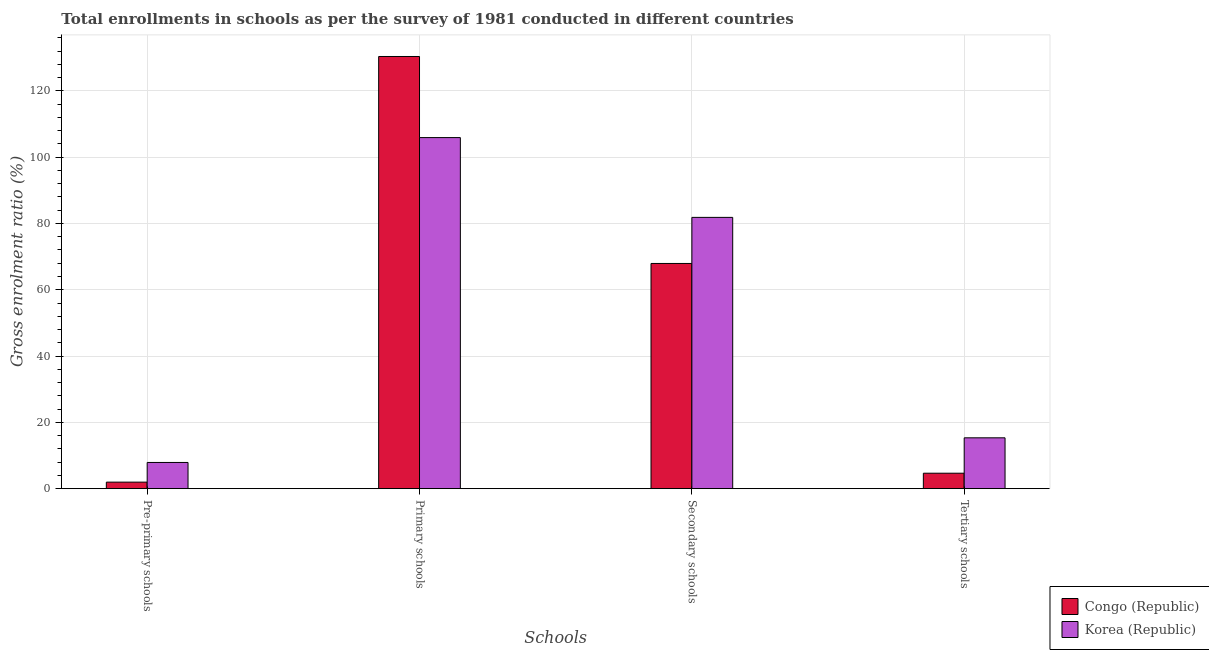Are the number of bars per tick equal to the number of legend labels?
Ensure brevity in your answer.  Yes. Are the number of bars on each tick of the X-axis equal?
Your response must be concise. Yes. How many bars are there on the 1st tick from the left?
Provide a short and direct response. 2. What is the label of the 2nd group of bars from the left?
Ensure brevity in your answer.  Primary schools. What is the gross enrolment ratio in primary schools in Korea (Republic)?
Provide a short and direct response. 105.91. Across all countries, what is the maximum gross enrolment ratio in pre-primary schools?
Give a very brief answer. 7.91. Across all countries, what is the minimum gross enrolment ratio in pre-primary schools?
Provide a succinct answer. 1.98. In which country was the gross enrolment ratio in tertiary schools maximum?
Your answer should be very brief. Korea (Republic). In which country was the gross enrolment ratio in primary schools minimum?
Offer a very short reply. Korea (Republic). What is the total gross enrolment ratio in secondary schools in the graph?
Make the answer very short. 149.78. What is the difference between the gross enrolment ratio in pre-primary schools in Korea (Republic) and that in Congo (Republic)?
Make the answer very short. 5.93. What is the difference between the gross enrolment ratio in secondary schools in Congo (Republic) and the gross enrolment ratio in primary schools in Korea (Republic)?
Ensure brevity in your answer.  -37.97. What is the average gross enrolment ratio in tertiary schools per country?
Your answer should be very brief. 10.01. What is the difference between the gross enrolment ratio in primary schools and gross enrolment ratio in pre-primary schools in Korea (Republic)?
Provide a short and direct response. 98. What is the ratio of the gross enrolment ratio in secondary schools in Korea (Republic) to that in Congo (Republic)?
Your answer should be very brief. 1.2. What is the difference between the highest and the second highest gross enrolment ratio in primary schools?
Keep it short and to the point. 24.47. What is the difference between the highest and the lowest gross enrolment ratio in pre-primary schools?
Your answer should be very brief. 5.93. What does the 1st bar from the left in Pre-primary schools represents?
Your answer should be very brief. Congo (Republic). What does the 2nd bar from the right in Primary schools represents?
Give a very brief answer. Congo (Republic). Is it the case that in every country, the sum of the gross enrolment ratio in pre-primary schools and gross enrolment ratio in primary schools is greater than the gross enrolment ratio in secondary schools?
Offer a terse response. Yes. Are all the bars in the graph horizontal?
Offer a terse response. No. Does the graph contain any zero values?
Provide a succinct answer. No. Where does the legend appear in the graph?
Provide a short and direct response. Bottom right. How many legend labels are there?
Your answer should be very brief. 2. What is the title of the graph?
Ensure brevity in your answer.  Total enrollments in schools as per the survey of 1981 conducted in different countries. Does "Middle East & North Africa (developing only)" appear as one of the legend labels in the graph?
Your response must be concise. No. What is the label or title of the X-axis?
Your answer should be very brief. Schools. What is the label or title of the Y-axis?
Your answer should be compact. Gross enrolment ratio (%). What is the Gross enrolment ratio (%) of Congo (Republic) in Pre-primary schools?
Your response must be concise. 1.98. What is the Gross enrolment ratio (%) in Korea (Republic) in Pre-primary schools?
Provide a short and direct response. 7.91. What is the Gross enrolment ratio (%) in Congo (Republic) in Primary schools?
Ensure brevity in your answer.  130.37. What is the Gross enrolment ratio (%) of Korea (Republic) in Primary schools?
Your answer should be very brief. 105.91. What is the Gross enrolment ratio (%) of Congo (Republic) in Secondary schools?
Provide a short and direct response. 67.94. What is the Gross enrolment ratio (%) of Korea (Republic) in Secondary schools?
Your answer should be very brief. 81.84. What is the Gross enrolment ratio (%) of Congo (Republic) in Tertiary schools?
Ensure brevity in your answer.  4.67. What is the Gross enrolment ratio (%) of Korea (Republic) in Tertiary schools?
Provide a short and direct response. 15.34. Across all Schools, what is the maximum Gross enrolment ratio (%) in Congo (Republic)?
Give a very brief answer. 130.37. Across all Schools, what is the maximum Gross enrolment ratio (%) in Korea (Republic)?
Make the answer very short. 105.91. Across all Schools, what is the minimum Gross enrolment ratio (%) of Congo (Republic)?
Your response must be concise. 1.98. Across all Schools, what is the minimum Gross enrolment ratio (%) in Korea (Republic)?
Provide a short and direct response. 7.91. What is the total Gross enrolment ratio (%) of Congo (Republic) in the graph?
Your answer should be compact. 204.95. What is the total Gross enrolment ratio (%) of Korea (Republic) in the graph?
Keep it short and to the point. 211. What is the difference between the Gross enrolment ratio (%) in Congo (Republic) in Pre-primary schools and that in Primary schools?
Make the answer very short. -128.4. What is the difference between the Gross enrolment ratio (%) of Korea (Republic) in Pre-primary schools and that in Primary schools?
Make the answer very short. -98. What is the difference between the Gross enrolment ratio (%) of Congo (Republic) in Pre-primary schools and that in Secondary schools?
Provide a succinct answer. -65.96. What is the difference between the Gross enrolment ratio (%) of Korea (Republic) in Pre-primary schools and that in Secondary schools?
Keep it short and to the point. -73.93. What is the difference between the Gross enrolment ratio (%) in Congo (Republic) in Pre-primary schools and that in Tertiary schools?
Provide a short and direct response. -2.69. What is the difference between the Gross enrolment ratio (%) in Korea (Republic) in Pre-primary schools and that in Tertiary schools?
Your answer should be compact. -7.44. What is the difference between the Gross enrolment ratio (%) of Congo (Republic) in Primary schools and that in Secondary schools?
Provide a short and direct response. 62.44. What is the difference between the Gross enrolment ratio (%) of Korea (Republic) in Primary schools and that in Secondary schools?
Give a very brief answer. 24.07. What is the difference between the Gross enrolment ratio (%) of Congo (Republic) in Primary schools and that in Tertiary schools?
Keep it short and to the point. 125.71. What is the difference between the Gross enrolment ratio (%) of Korea (Republic) in Primary schools and that in Tertiary schools?
Provide a succinct answer. 90.56. What is the difference between the Gross enrolment ratio (%) in Congo (Republic) in Secondary schools and that in Tertiary schools?
Keep it short and to the point. 63.27. What is the difference between the Gross enrolment ratio (%) in Korea (Republic) in Secondary schools and that in Tertiary schools?
Offer a terse response. 66.5. What is the difference between the Gross enrolment ratio (%) in Congo (Republic) in Pre-primary schools and the Gross enrolment ratio (%) in Korea (Republic) in Primary schools?
Your answer should be compact. -103.93. What is the difference between the Gross enrolment ratio (%) in Congo (Republic) in Pre-primary schools and the Gross enrolment ratio (%) in Korea (Republic) in Secondary schools?
Your answer should be very brief. -79.87. What is the difference between the Gross enrolment ratio (%) in Congo (Republic) in Pre-primary schools and the Gross enrolment ratio (%) in Korea (Republic) in Tertiary schools?
Your answer should be compact. -13.37. What is the difference between the Gross enrolment ratio (%) of Congo (Republic) in Primary schools and the Gross enrolment ratio (%) of Korea (Republic) in Secondary schools?
Your response must be concise. 48.53. What is the difference between the Gross enrolment ratio (%) of Congo (Republic) in Primary schools and the Gross enrolment ratio (%) of Korea (Republic) in Tertiary schools?
Ensure brevity in your answer.  115.03. What is the difference between the Gross enrolment ratio (%) in Congo (Republic) in Secondary schools and the Gross enrolment ratio (%) in Korea (Republic) in Tertiary schools?
Ensure brevity in your answer.  52.59. What is the average Gross enrolment ratio (%) in Congo (Republic) per Schools?
Make the answer very short. 51.24. What is the average Gross enrolment ratio (%) of Korea (Republic) per Schools?
Your answer should be very brief. 52.75. What is the difference between the Gross enrolment ratio (%) of Congo (Republic) and Gross enrolment ratio (%) of Korea (Republic) in Pre-primary schools?
Your answer should be compact. -5.93. What is the difference between the Gross enrolment ratio (%) of Congo (Republic) and Gross enrolment ratio (%) of Korea (Republic) in Primary schools?
Provide a succinct answer. 24.47. What is the difference between the Gross enrolment ratio (%) of Congo (Republic) and Gross enrolment ratio (%) of Korea (Republic) in Secondary schools?
Keep it short and to the point. -13.9. What is the difference between the Gross enrolment ratio (%) of Congo (Republic) and Gross enrolment ratio (%) of Korea (Republic) in Tertiary schools?
Provide a short and direct response. -10.68. What is the ratio of the Gross enrolment ratio (%) of Congo (Republic) in Pre-primary schools to that in Primary schools?
Offer a very short reply. 0.02. What is the ratio of the Gross enrolment ratio (%) in Korea (Republic) in Pre-primary schools to that in Primary schools?
Keep it short and to the point. 0.07. What is the ratio of the Gross enrolment ratio (%) in Congo (Republic) in Pre-primary schools to that in Secondary schools?
Ensure brevity in your answer.  0.03. What is the ratio of the Gross enrolment ratio (%) of Korea (Republic) in Pre-primary schools to that in Secondary schools?
Your answer should be very brief. 0.1. What is the ratio of the Gross enrolment ratio (%) of Congo (Republic) in Pre-primary schools to that in Tertiary schools?
Your answer should be compact. 0.42. What is the ratio of the Gross enrolment ratio (%) of Korea (Republic) in Pre-primary schools to that in Tertiary schools?
Make the answer very short. 0.52. What is the ratio of the Gross enrolment ratio (%) of Congo (Republic) in Primary schools to that in Secondary schools?
Keep it short and to the point. 1.92. What is the ratio of the Gross enrolment ratio (%) of Korea (Republic) in Primary schools to that in Secondary schools?
Your answer should be very brief. 1.29. What is the ratio of the Gross enrolment ratio (%) in Congo (Republic) in Primary schools to that in Tertiary schools?
Ensure brevity in your answer.  27.94. What is the ratio of the Gross enrolment ratio (%) of Korea (Republic) in Primary schools to that in Tertiary schools?
Make the answer very short. 6.9. What is the ratio of the Gross enrolment ratio (%) of Congo (Republic) in Secondary schools to that in Tertiary schools?
Make the answer very short. 14.56. What is the ratio of the Gross enrolment ratio (%) of Korea (Republic) in Secondary schools to that in Tertiary schools?
Provide a short and direct response. 5.33. What is the difference between the highest and the second highest Gross enrolment ratio (%) of Congo (Republic)?
Your answer should be compact. 62.44. What is the difference between the highest and the second highest Gross enrolment ratio (%) in Korea (Republic)?
Your response must be concise. 24.07. What is the difference between the highest and the lowest Gross enrolment ratio (%) in Congo (Republic)?
Your response must be concise. 128.4. What is the difference between the highest and the lowest Gross enrolment ratio (%) in Korea (Republic)?
Offer a very short reply. 98. 